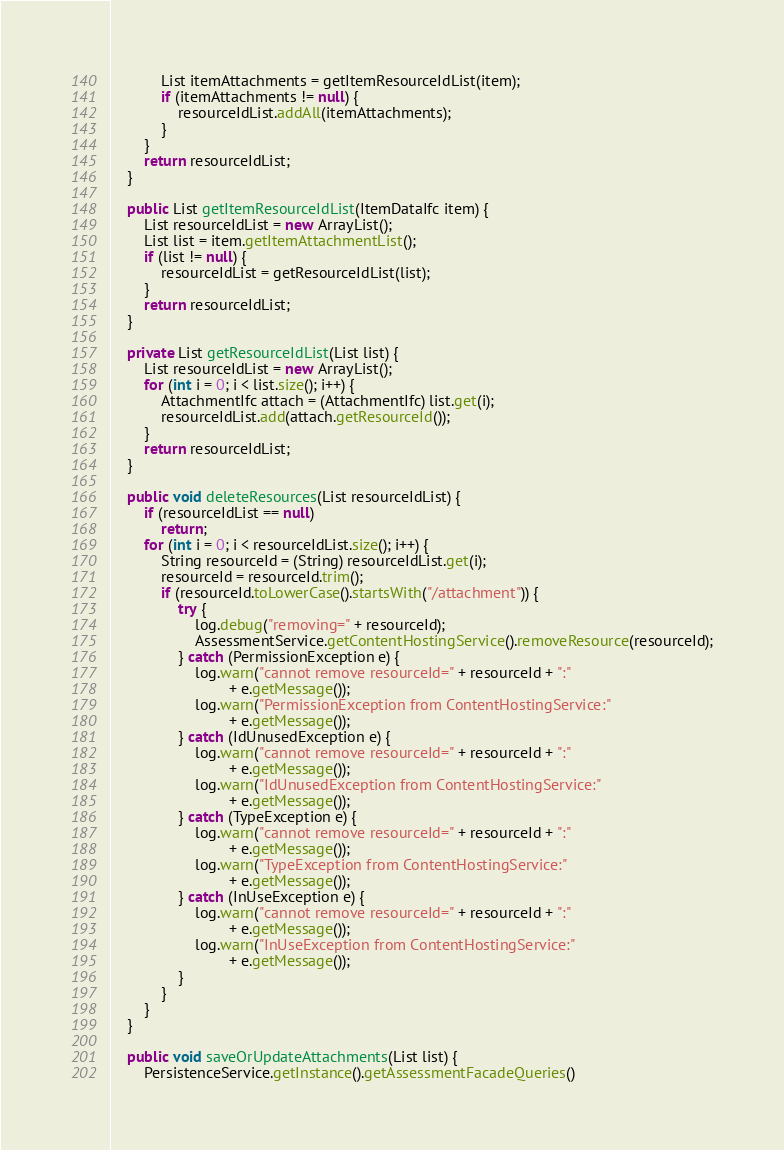<code> <loc_0><loc_0><loc_500><loc_500><_Java_>			List itemAttachments = getItemResourceIdList(item);
			if (itemAttachments != null) {
				resourceIdList.addAll(itemAttachments);
			}
		}
		return resourceIdList;
	}

	public List getItemResourceIdList(ItemDataIfc item) {
		List resourceIdList = new ArrayList();
		List list = item.getItemAttachmentList();
		if (list != null) {
			resourceIdList = getResourceIdList(list);
		}
		return resourceIdList;
	}

	private List getResourceIdList(List list) {
		List resourceIdList = new ArrayList();
		for (int i = 0; i < list.size(); i++) {
			AttachmentIfc attach = (AttachmentIfc) list.get(i);
			resourceIdList.add(attach.getResourceId());
		}
		return resourceIdList;
	}

	public void deleteResources(List resourceIdList) {
		if (resourceIdList == null)
			return;
		for (int i = 0; i < resourceIdList.size(); i++) {
			String resourceId = (String) resourceIdList.get(i);
			resourceId = resourceId.trim();
			if (resourceId.toLowerCase().startsWith("/attachment")) {
				try {
					log.debug("removing=" + resourceId);
					AssessmentService.getContentHostingService().removeResource(resourceId);
				} catch (PermissionException e) {
					log.warn("cannot remove resourceId=" + resourceId + ":"
							+ e.getMessage());
					log.warn("PermissionException from ContentHostingService:"
							+ e.getMessage());
				} catch (IdUnusedException e) {
					log.warn("cannot remove resourceId=" + resourceId + ":"
							+ e.getMessage());
					log.warn("IdUnusedException from ContentHostingService:"
							+ e.getMessage());
				} catch (TypeException e) {
					log.warn("cannot remove resourceId=" + resourceId + ":"
							+ e.getMessage());
					log.warn("TypeException from ContentHostingService:"
							+ e.getMessage());
				} catch (InUseException e) {
					log.warn("cannot remove resourceId=" + resourceId + ":"
							+ e.getMessage());
					log.warn("InUseException from ContentHostingService:"
							+ e.getMessage());
				}
			}
		}
	}

	public void saveOrUpdateAttachments(List list) {
		PersistenceService.getInstance().getAssessmentFacadeQueries()</code> 